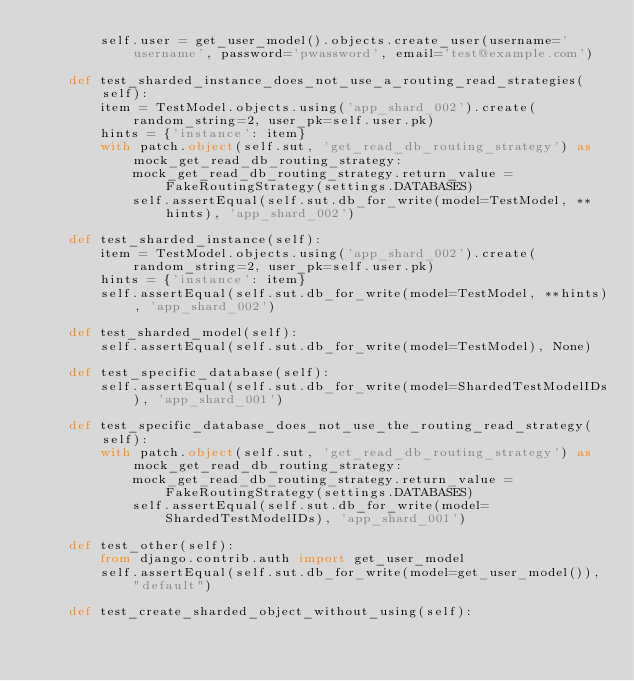Convert code to text. <code><loc_0><loc_0><loc_500><loc_500><_Python_>        self.user = get_user_model().objects.create_user(username='username', password='pwassword', email='test@example.com')

    def test_sharded_instance_does_not_use_a_routing_read_strategies(self):
        item = TestModel.objects.using('app_shard_002').create(random_string=2, user_pk=self.user.pk)
        hints = {'instance': item}
        with patch.object(self.sut, 'get_read_db_routing_strategy') as mock_get_read_db_routing_strategy:
            mock_get_read_db_routing_strategy.return_value = FakeRoutingStrategy(settings.DATABASES)
            self.assertEqual(self.sut.db_for_write(model=TestModel, **hints), 'app_shard_002')

    def test_sharded_instance(self):
        item = TestModel.objects.using('app_shard_002').create(random_string=2, user_pk=self.user.pk)
        hints = {'instance': item}
        self.assertEqual(self.sut.db_for_write(model=TestModel, **hints), 'app_shard_002')

    def test_sharded_model(self):
        self.assertEqual(self.sut.db_for_write(model=TestModel), None)

    def test_specific_database(self):
        self.assertEqual(self.sut.db_for_write(model=ShardedTestModelIDs), 'app_shard_001')

    def test_specific_database_does_not_use_the_routing_read_strategy(self):
        with patch.object(self.sut, 'get_read_db_routing_strategy') as mock_get_read_db_routing_strategy:
            mock_get_read_db_routing_strategy.return_value = FakeRoutingStrategy(settings.DATABASES)
            self.assertEqual(self.sut.db_for_write(model=ShardedTestModelIDs), 'app_shard_001')

    def test_other(self):
        from django.contrib.auth import get_user_model
        self.assertEqual(self.sut.db_for_write(model=get_user_model()), "default")

    def test_create_sharded_object_without_using(self):</code> 